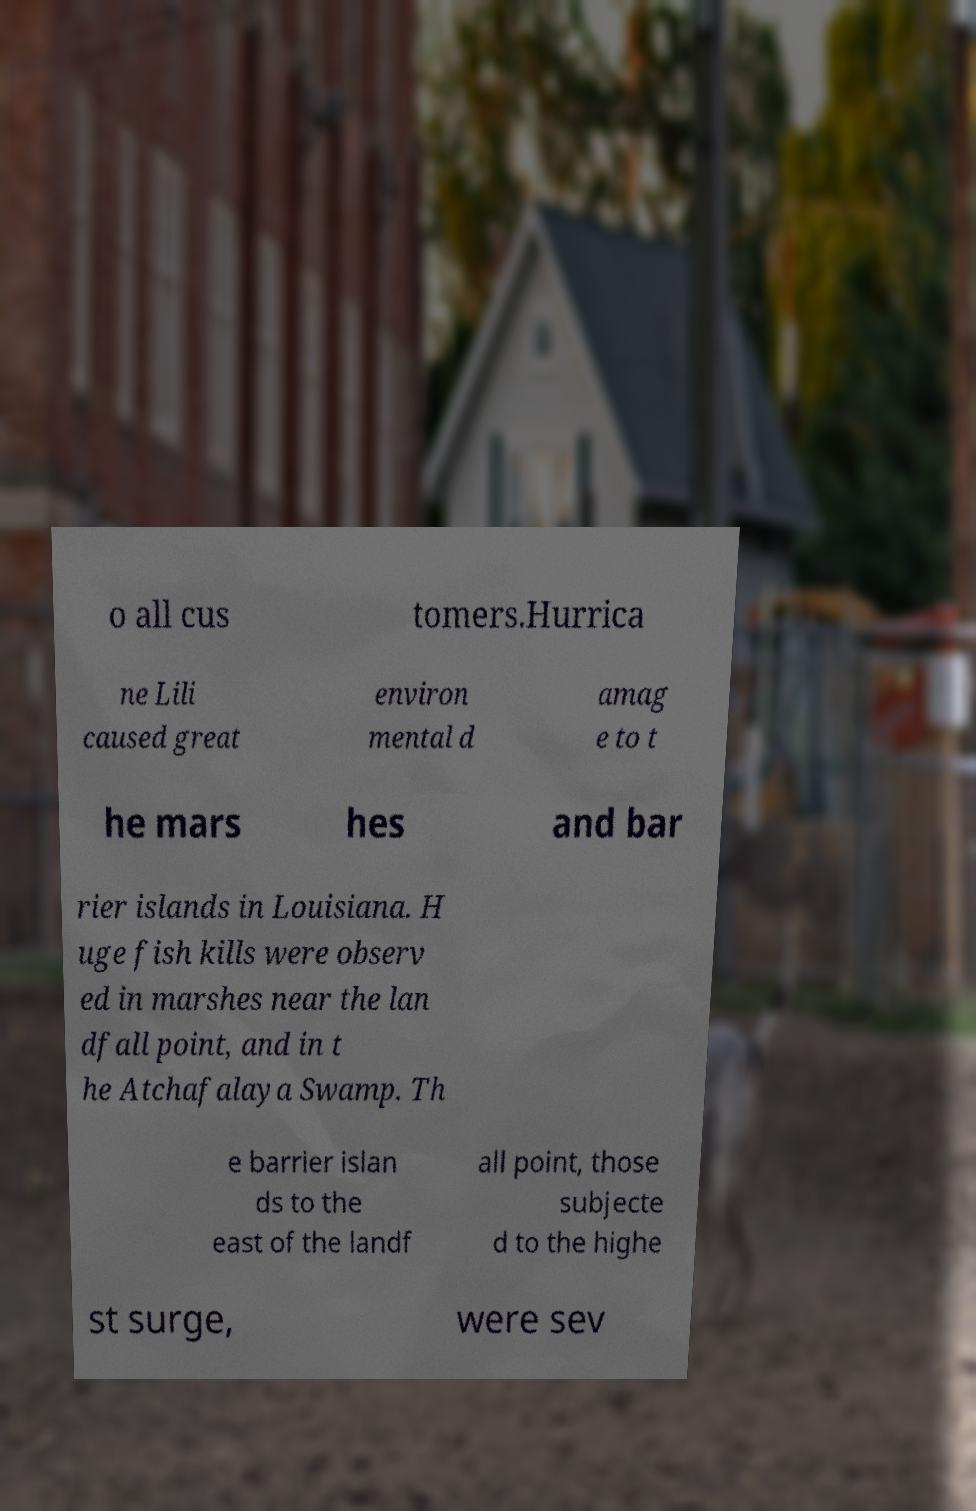I need the written content from this picture converted into text. Can you do that? o all cus tomers.Hurrica ne Lili caused great environ mental d amag e to t he mars hes and bar rier islands in Louisiana. H uge fish kills were observ ed in marshes near the lan dfall point, and in t he Atchafalaya Swamp. Th e barrier islan ds to the east of the landf all point, those subjecte d to the highe st surge, were sev 